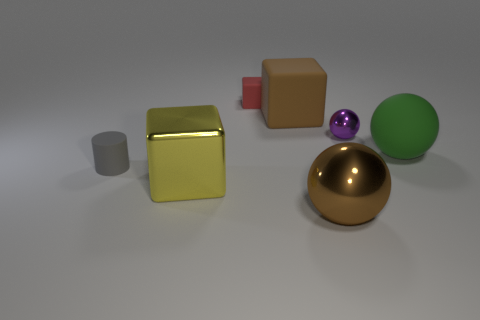What materials do the objects in the image appear to be made of? The objects in the image appear to have different materials. The golden sphere looks metallic, with a shiny surface reflecting the light, suggestive of a polished metal. The green and purple spheres seem glossy, perhaps made of plastic or glass. The cubes have more of a matte finish, possibly made of a solid, non-reflective material like rubber or a similar substance. 